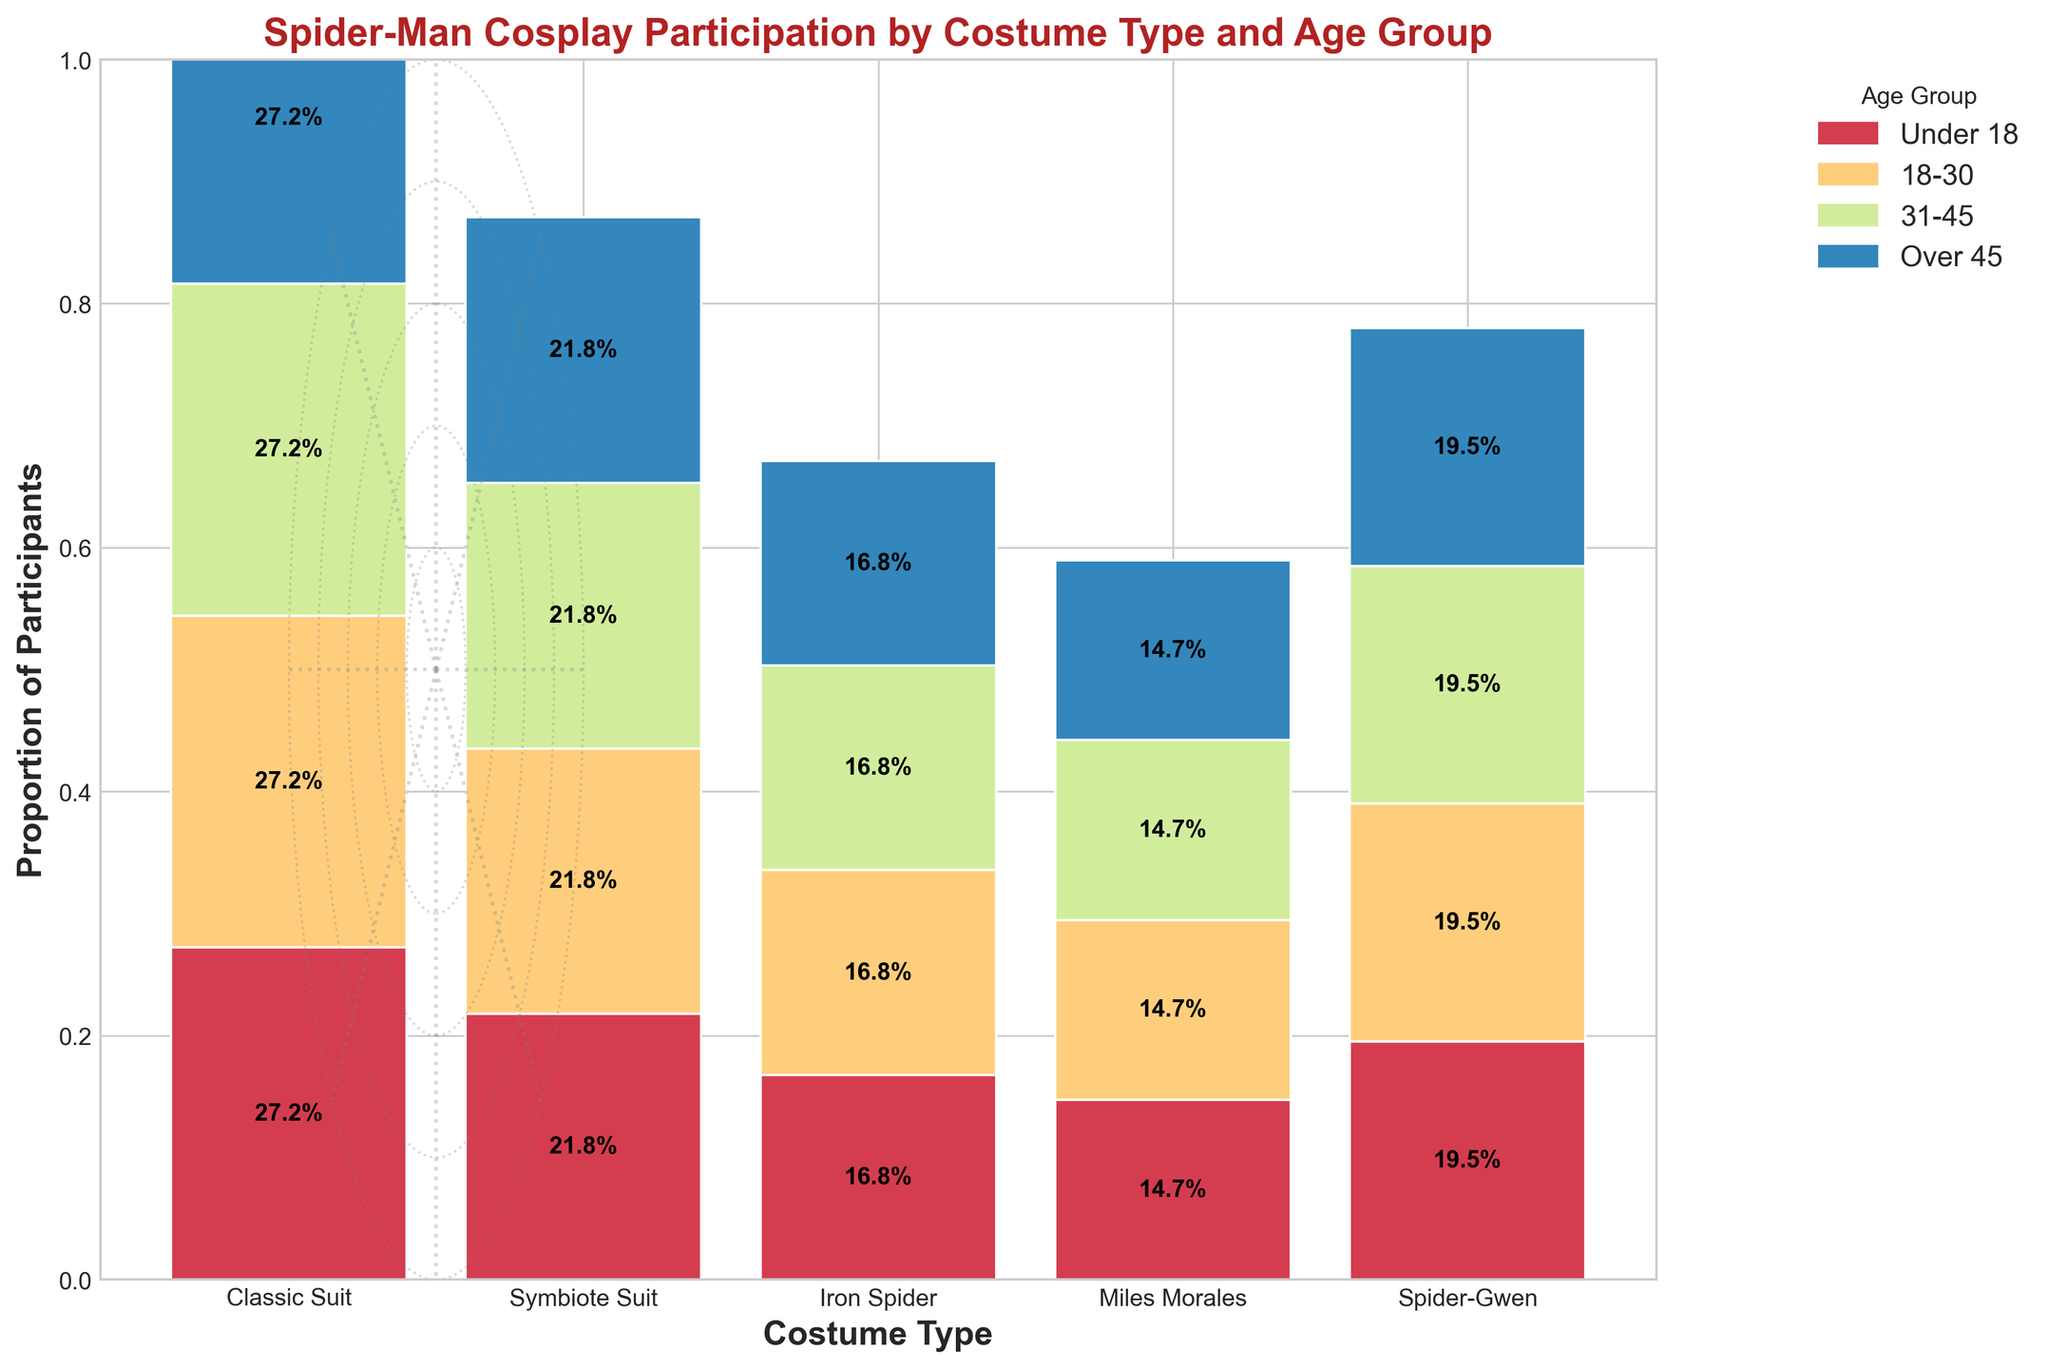Which costume type has the highest proportion of participants in the age group 18-30? First, look at the total height of all bars within the age group 18-30. Identify which costume type's bar segment is the largest in this specific age group.
Answer: Classic Suit What is the overall proportion of participants wearing the Iron Spider costume? To find the overall proportion, sum the heights of all the segments corresponding to the Iron Spider costume across all age groups and then interpret the relative height compared to the total height of the bars.
Answer: About 0.245 or 24.5% Which age group has the smallest proportion of participants overall? Compare the height of the stacked bar segments for each age group across all costume types. The smallest total height indicates the age group with the smallest proportion of participants.
Answer: Over 45 How many costume types are represented in the plot? Count the number of unique bars (costumes) on the x-axis of the plot.
Answer: 5 Which age group has the highest proportion of participants wearing the Symbiote Suit? Look at the heights of each segment in the Symbiote Suit bar and identify which age group's segment is the tallest.
Answer: 18-30 Compare the proportions of participants under 18 wearing Spider-Gwen and those over 45 wearing Miles Morales. Which is higher? Check the height of the Under 18 segment in the Spider-Gwen bar and compare it with the Over 45 segment in the Miles Morales bar.
Answer: Under 18 wearing Spider-Gwen What is the title of the figure? Find the text at the top of the plot, which indicates the title.
Answer: Spider-Man Cosplay Participation by Costume Type and Age Group How does the proportion of participants in the 31-45 age group wearing the Classic Suit compare to those wearing the Iron Spider? Compare the respective heights of the segments for the 31-45 age group within the Classic Suit and Iron Spider bars.
Answer: Higher for Classic Suit Identify the costume type with the maximum proportion of participants over 45. Look at the heights of the segments corresponding to Over 45 across all costume bars. The highest segment identifies the costume type.
Answer: Classic Suit What is the color scheme used to differentiate age groups? Identify the range of colors used in the plot to distinguish different age groups. These are visible by assessing the bar segment colors.
Answer: Spectral colors 